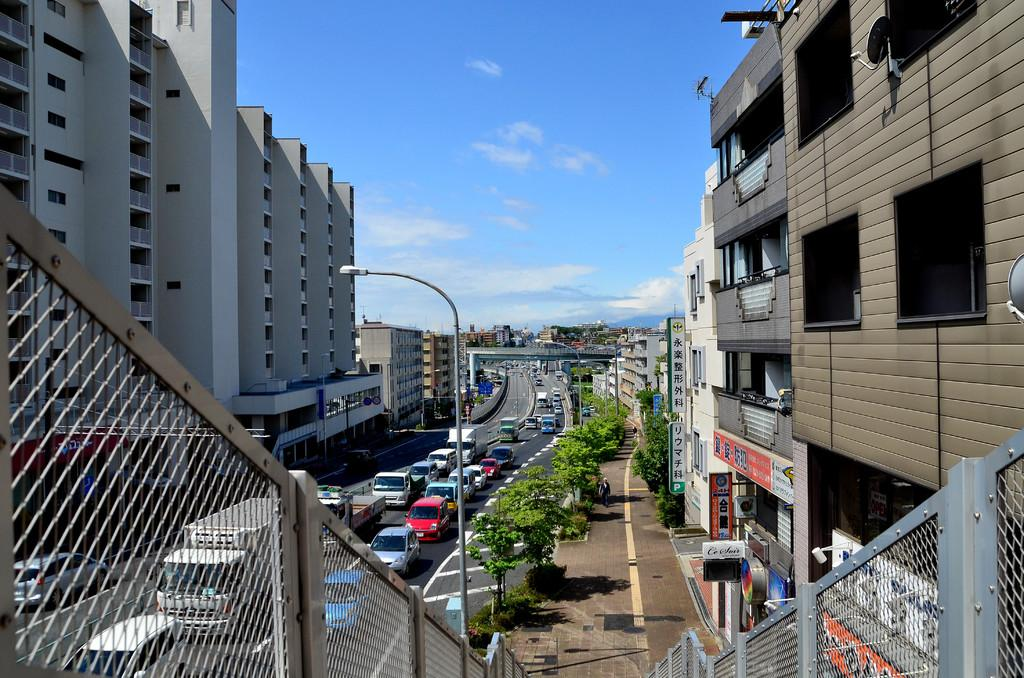What is happening on the road in the image? There are vehicles passing on the road in the image. What can be seen on either side of the road? There are trees and buildings on either side of the road in the image. Can you identify any street furniture in the image? Yes, there is a lamp post in the image. How does the guide help the decision-making process in the image? There is no guide or decision-making process depicted in the image; it only shows vehicles passing on the road with trees and buildings on either side. 